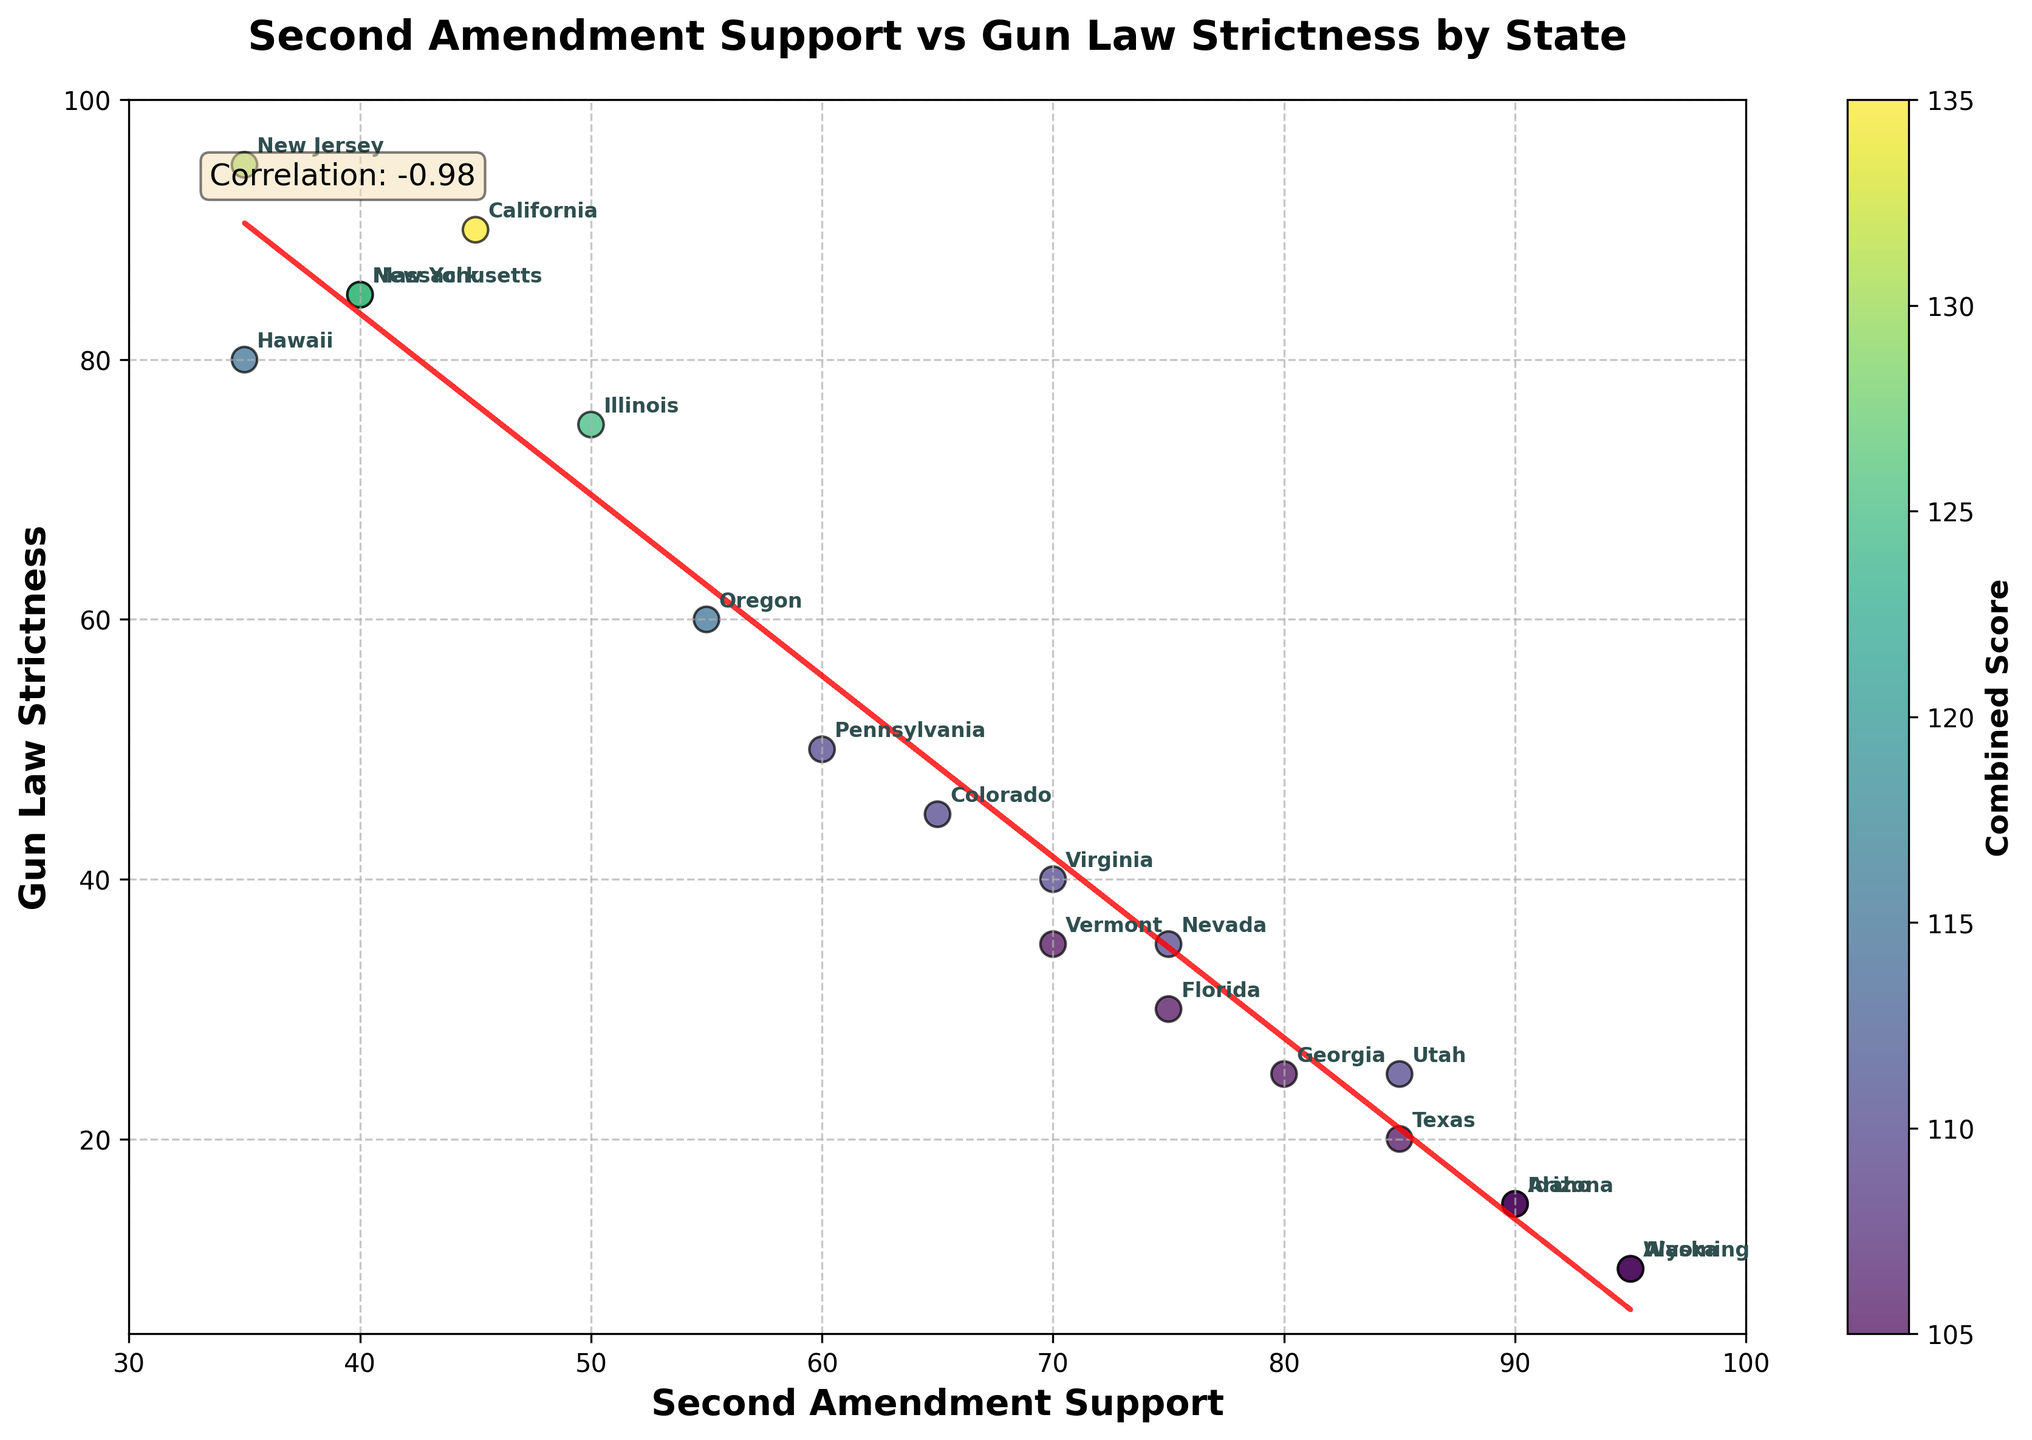How many states have a Second Amendment support level above 80? We identify Texas, Arizona, Utah, Idaho, and Alaska as the states with support levels above 80 by looking at their labeled positions on the x-axis.
Answer: 5 Which state has the highest Gun Law Strictness? New Jersey is at the highest point on the y-axis compared to all other states, indicating the strictest gun laws.
Answer: New Jersey What's the title of the figure? The figure title is displayed at the top of the plot.
Answer: Second Amendment Support vs Gun Law Strictness by State Which states show both high Second Amendment support and low Gun Law Strictness? Texas, Arizona, Idaho, and Alaska have high support (right side of the graph) and low strictness (bottom of the graph).
Answer: Texas, Arizona, Idaho, Alaska Identify a state with low Second Amendment support and high Gun Law Strictness. California, New York, Massachusetts, and New Jersey are on the left side of the graph, with high positions on the y-axis, indicating low support and high strictness.
Answer: California How many states have Gun Law Strictness levels below 20? Wyoming, Arizona, Idaho, and Alaska are located below the 20-mark on the y-axis.
Answer: 4 What trend does the line of best fit show between Second Amendment support and Gun Law Strictness? The red dashed trend line slopes downward, indicating an inverse relationship: as Second Amendment support increases, Gun Law Strictness tends to decrease.
Answer: Inverse relationship Which states have similar levels of both Second Amendment support and Gun Law Strictness? States like Vermont and Virginia are near each other in the mid-range of both axes, indicating similar levels.
Answer: Vermont and Virginia 